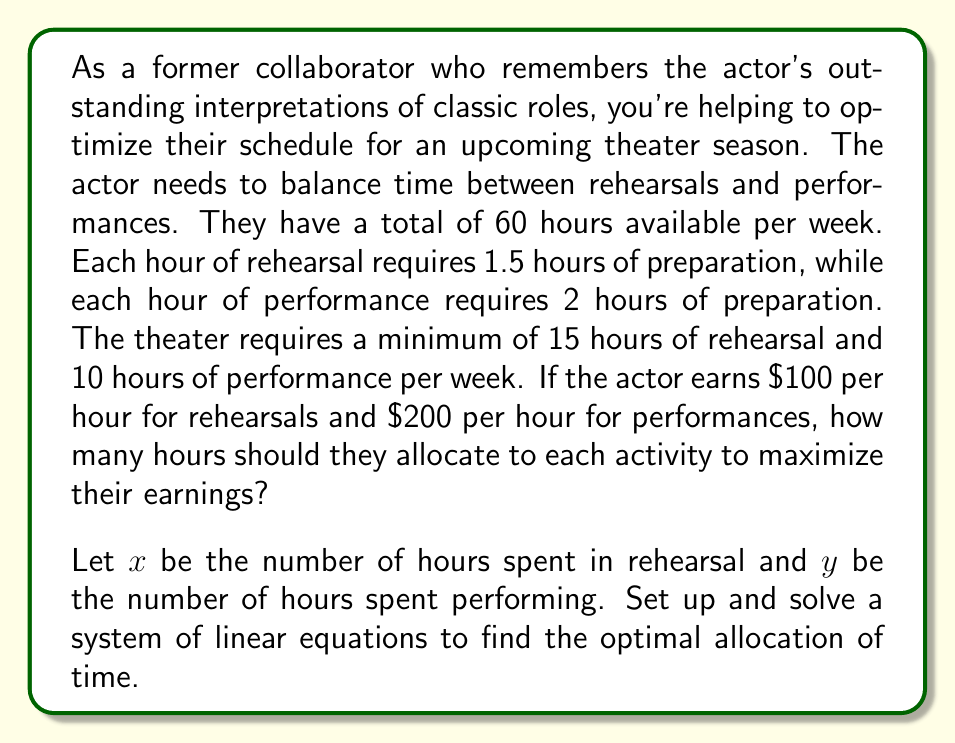Give your solution to this math problem. Let's approach this step-by-step:

1) First, let's set up our constraints:

   Time constraint: $x + y + 1.5x + 2y \leq 60$
   Simplifying: $2.5x + 3y \leq 60$

   Minimum rehearsal time: $x \geq 15$
   Minimum performance time: $y \geq 10$

2) Our objective function (earnings) is:
   $E = 100x + 200y$

3) We need to maximize E subject to our constraints. This is a linear programming problem, which we can solve graphically or using the simplex method. For this problem, we'll use the graphical method.

4) Let's graph our constraints:
   
   $2.5x + 3y = 60$
   $x = 15$
   $y = 10$

   [asy]
   import geometry;
   
   size(200);
   
   real xmax = 30;
   real ymax = 25;
   
   xaxis("x", 0, xmax, arrow=Arrow);
   yaxis("y", 0, ymax, arrow=Arrow);
   
   draw((0,20)--(24,0), blue);
   draw((15,0)--(15,ymax), red);
   draw((0,10)--(xmax,10), green);
   
   label("$2.5x + 3y = 60$", (12,10), SW, blue);
   label("$x = 15$", (15,22), W, red);
   label("$y = 10$", (25,10), S, green);
   
   fill((15,10)--(24,0)--(15,0)--cycle, lightgray);
   
   dot((15,10));
   dot((24,0));
   dot((15,0));
   
   label("(15,10)", (15,10), NE);
   label("(24,0)", (24,0), SE);
   label("(15,0)", (15,0), SW);
   
   [/asy]

5) The feasible region is the shaded area. The optimal solution will be at one of the corner points of this region.

6) Let's evaluate our objective function at each corner point:

   At (15, 10): $E = 100(15) + 200(10) = 3500$
   At (24, 0): $E = 100(24) + 200(0) = 2400$
   At (15, 0): $E = 100(15) + 200(0) = 1500$

7) The maximum earnings occur at the point (15, 10).
Answer: The actor should spend 15 hours in rehearsal and 10 hours performing per week to maximize their earnings at $3500. 